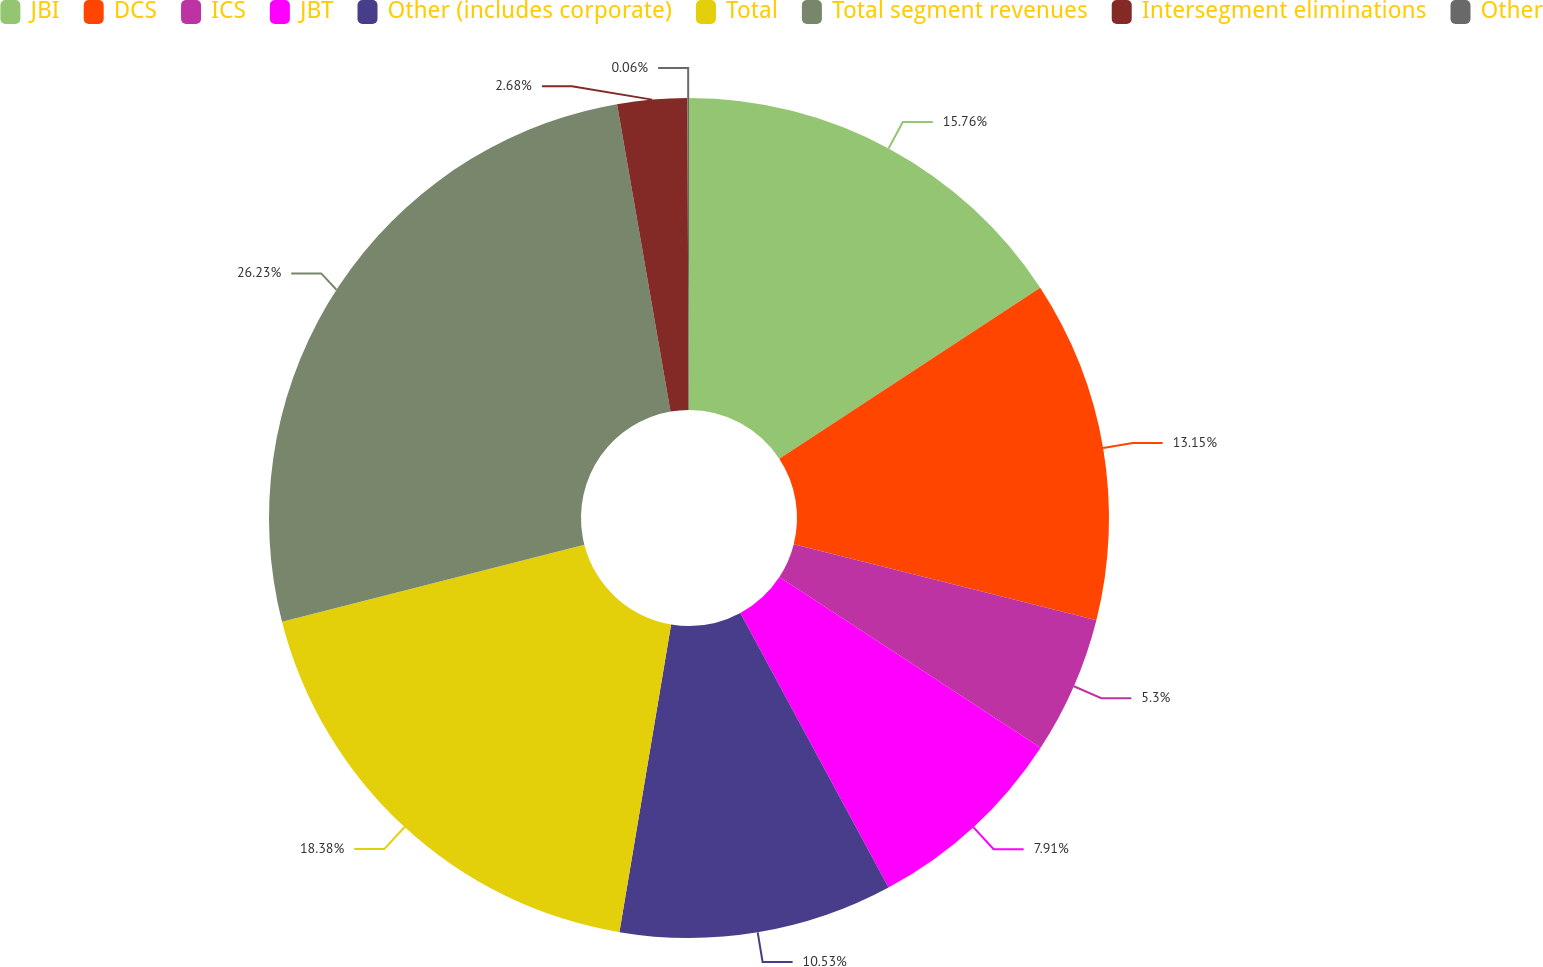<chart> <loc_0><loc_0><loc_500><loc_500><pie_chart><fcel>JBI<fcel>DCS<fcel>ICS<fcel>JBT<fcel>Other (includes corporate)<fcel>Total<fcel>Total segment revenues<fcel>Intersegment eliminations<fcel>Other<nl><fcel>15.76%<fcel>13.15%<fcel>5.3%<fcel>7.91%<fcel>10.53%<fcel>18.38%<fcel>26.23%<fcel>2.68%<fcel>0.06%<nl></chart> 